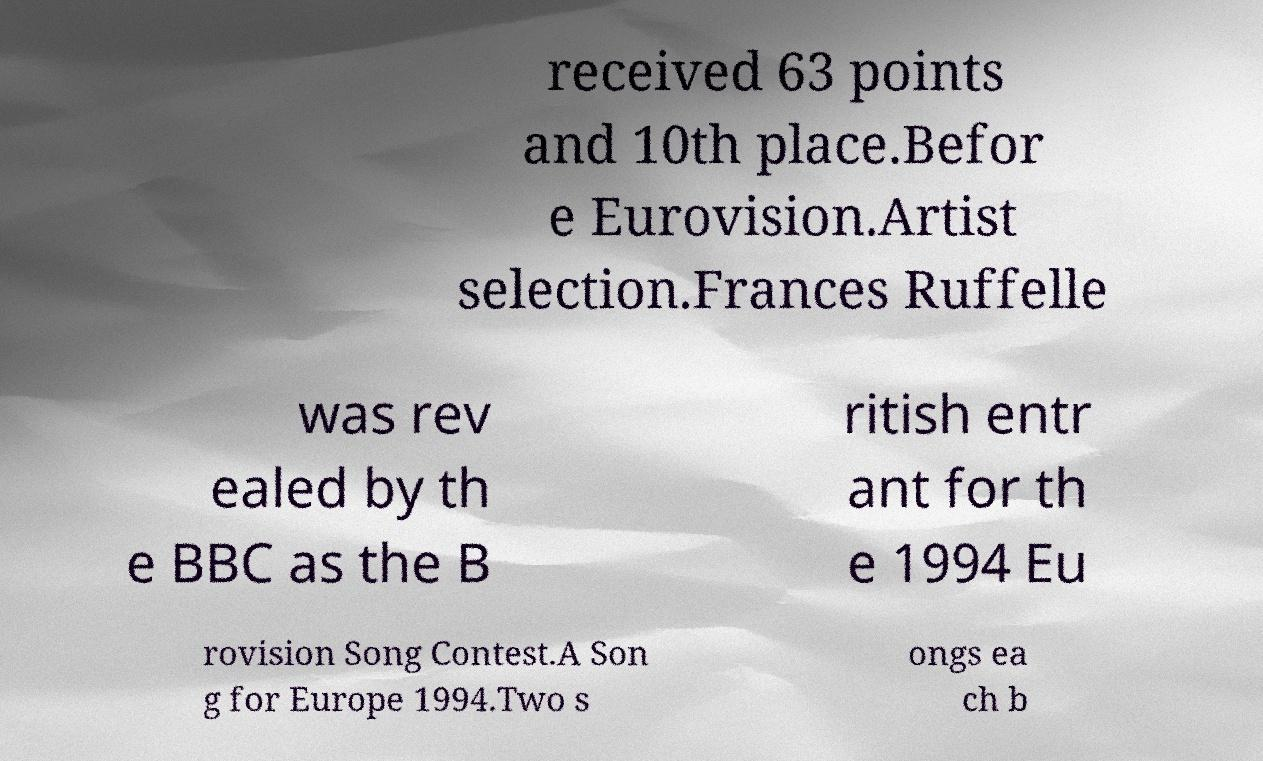Please read and relay the text visible in this image. What does it say? received 63 points and 10th place.Befor e Eurovision.Artist selection.Frances Ruffelle was rev ealed by th e BBC as the B ritish entr ant for th e 1994 Eu rovision Song Contest.A Son g for Europe 1994.Two s ongs ea ch b 